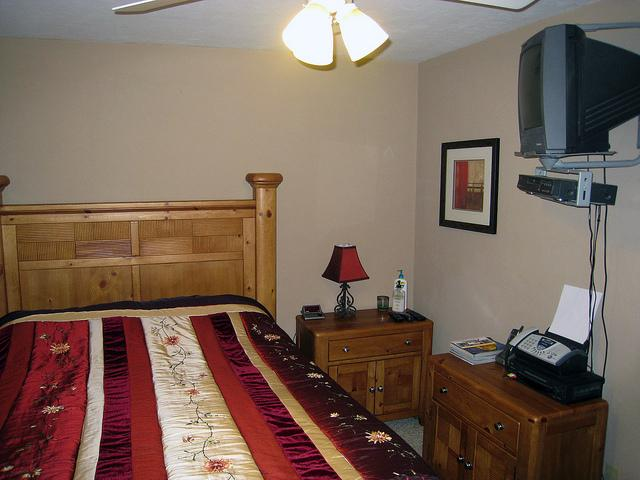What color is the main stripe on the right side of the queen sized bed?

Choices:
A) yellow
B) white
C) pink
D) red red 